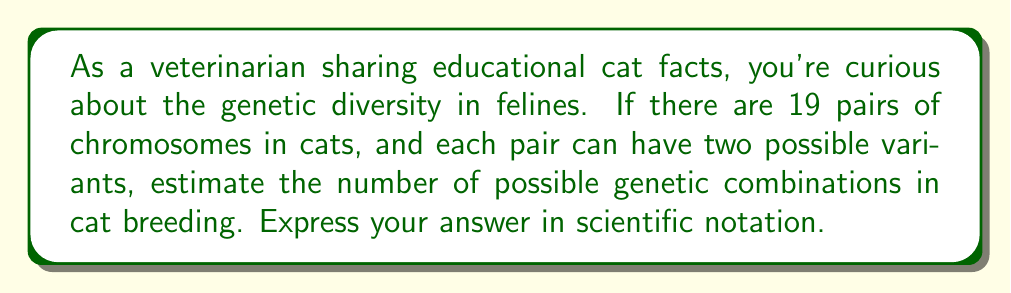Show me your answer to this math problem. To estimate the number of possible genetic combinations in cat breeding, we need to follow these steps:

1. Understand the given information:
   - Cats have 19 pairs of chromosomes
   - Each pair can have two possible variants

2. Calculate the number of possibilities for each chromosome pair:
   - For each pair, there are 2 possibilities
   - This can be represented as $2^1 = 2$

3. Calculate the total number of combinations:
   - We need to consider all 19 pairs of chromosomes
   - The total number of combinations is $2^{19}$

4. Compute $2^{19}$:
   $2^{19} = 524,288$

5. Express the result in scientific notation:
   $524,288 = 5.24288 \times 10^5$

Therefore, the estimated number of possible genetic combinations in cat breeding, based on this simplified model, is approximately $5.24 \times 10^5$.

Note: This is a simplified estimate. In reality, genetic combinations are much more complex due to factors like genetic recombination, mutations, and multiple alleles for each gene.
Answer: $5.24 \times 10^5$ 